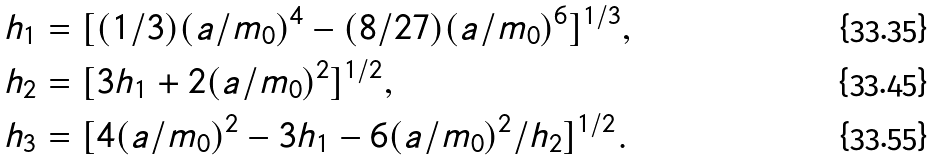<formula> <loc_0><loc_0><loc_500><loc_500>h _ { 1 } & = [ ( 1 / 3 ) ( a / m _ { 0 } ) ^ { 4 } - ( 8 / 2 7 ) ( a / m _ { 0 } ) ^ { 6 } ] ^ { 1 / 3 } , \\ h _ { 2 } & = [ 3 h _ { 1 } + 2 ( a / m _ { 0 } ) ^ { 2 } ] ^ { 1 / 2 } , \\ h _ { 3 } & = [ 4 ( a / m _ { 0 } ) ^ { 2 } - 3 h _ { 1 } - 6 ( a / m _ { 0 } ) ^ { 2 } / h _ { 2 } ] ^ { 1 / 2 } .</formula> 